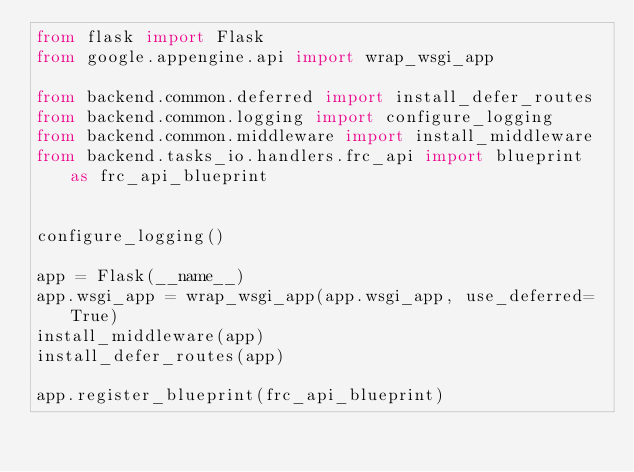<code> <loc_0><loc_0><loc_500><loc_500><_Python_>from flask import Flask
from google.appengine.api import wrap_wsgi_app

from backend.common.deferred import install_defer_routes
from backend.common.logging import configure_logging
from backend.common.middleware import install_middleware
from backend.tasks_io.handlers.frc_api import blueprint as frc_api_blueprint


configure_logging()

app = Flask(__name__)
app.wsgi_app = wrap_wsgi_app(app.wsgi_app, use_deferred=True)
install_middleware(app)
install_defer_routes(app)

app.register_blueprint(frc_api_blueprint)
</code> 